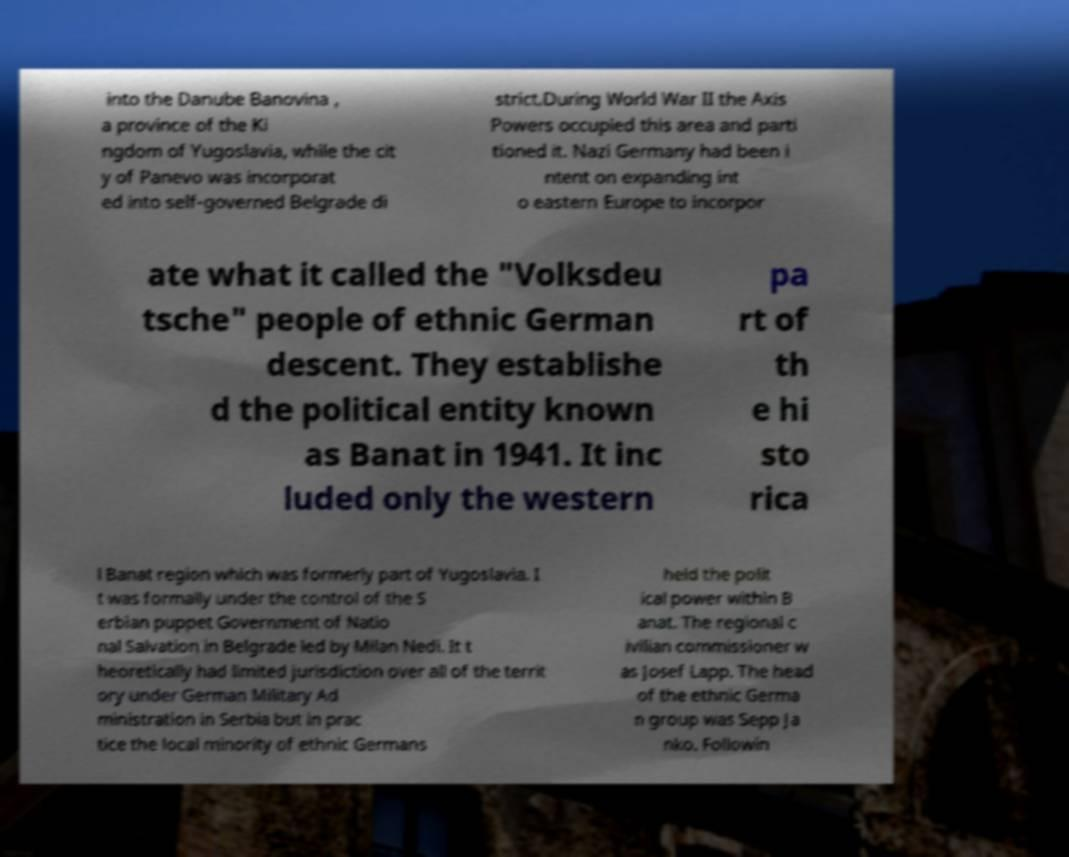I need the written content from this picture converted into text. Can you do that? into the Danube Banovina , a province of the Ki ngdom of Yugoslavia, while the cit y of Panevo was incorporat ed into self-governed Belgrade di strict.During World War II the Axis Powers occupied this area and parti tioned it. Nazi Germany had been i ntent on expanding int o eastern Europe to incorpor ate what it called the "Volksdeu tsche" people of ethnic German descent. They establishe d the political entity known as Banat in 1941. It inc luded only the western pa rt of th e hi sto rica l Banat region which was formerly part of Yugoslavia. I t was formally under the control of the S erbian puppet Government of Natio nal Salvation in Belgrade led by Milan Nedi. It t heoretically had limited jurisdiction over all of the territ ory under German Military Ad ministration in Serbia but in prac tice the local minority of ethnic Germans held the polit ical power within B anat. The regional c ivilian commissioner w as Josef Lapp. The head of the ethnic Germa n group was Sepp Ja nko. Followin 